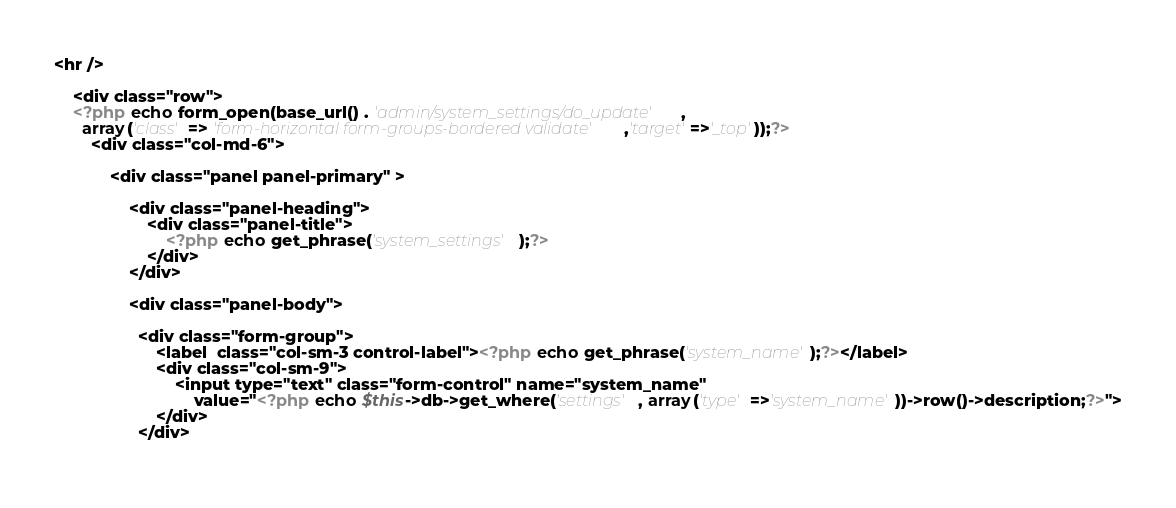Convert code to text. <code><loc_0><loc_0><loc_500><loc_500><_PHP_><hr />

    <div class="row">
    <?php echo form_open(base_url() . 'admin/system_settings/do_update' , 
      array('class' => 'form-horizontal form-groups-bordered validate','target'=>'_top'));?>
        <div class="col-md-6">
            
            <div class="panel panel-primary" >
            
                <div class="panel-heading">
                    <div class="panel-title">
                        <?php echo get_phrase('system_settings');?>
                    </div>
                </div>
                
                <div class="panel-body">
                    
                  <div class="form-group">
                      <label  class="col-sm-3 control-label"><?php echo get_phrase('system_name');?></label>
                      <div class="col-sm-9">
                          <input type="text" class="form-control" name="system_name" 
                              value="<?php echo $this->db->get_where('settings' , array('type' =>'system_name'))->row()->description;?>">
                      </div>
                  </div>
                    </code> 